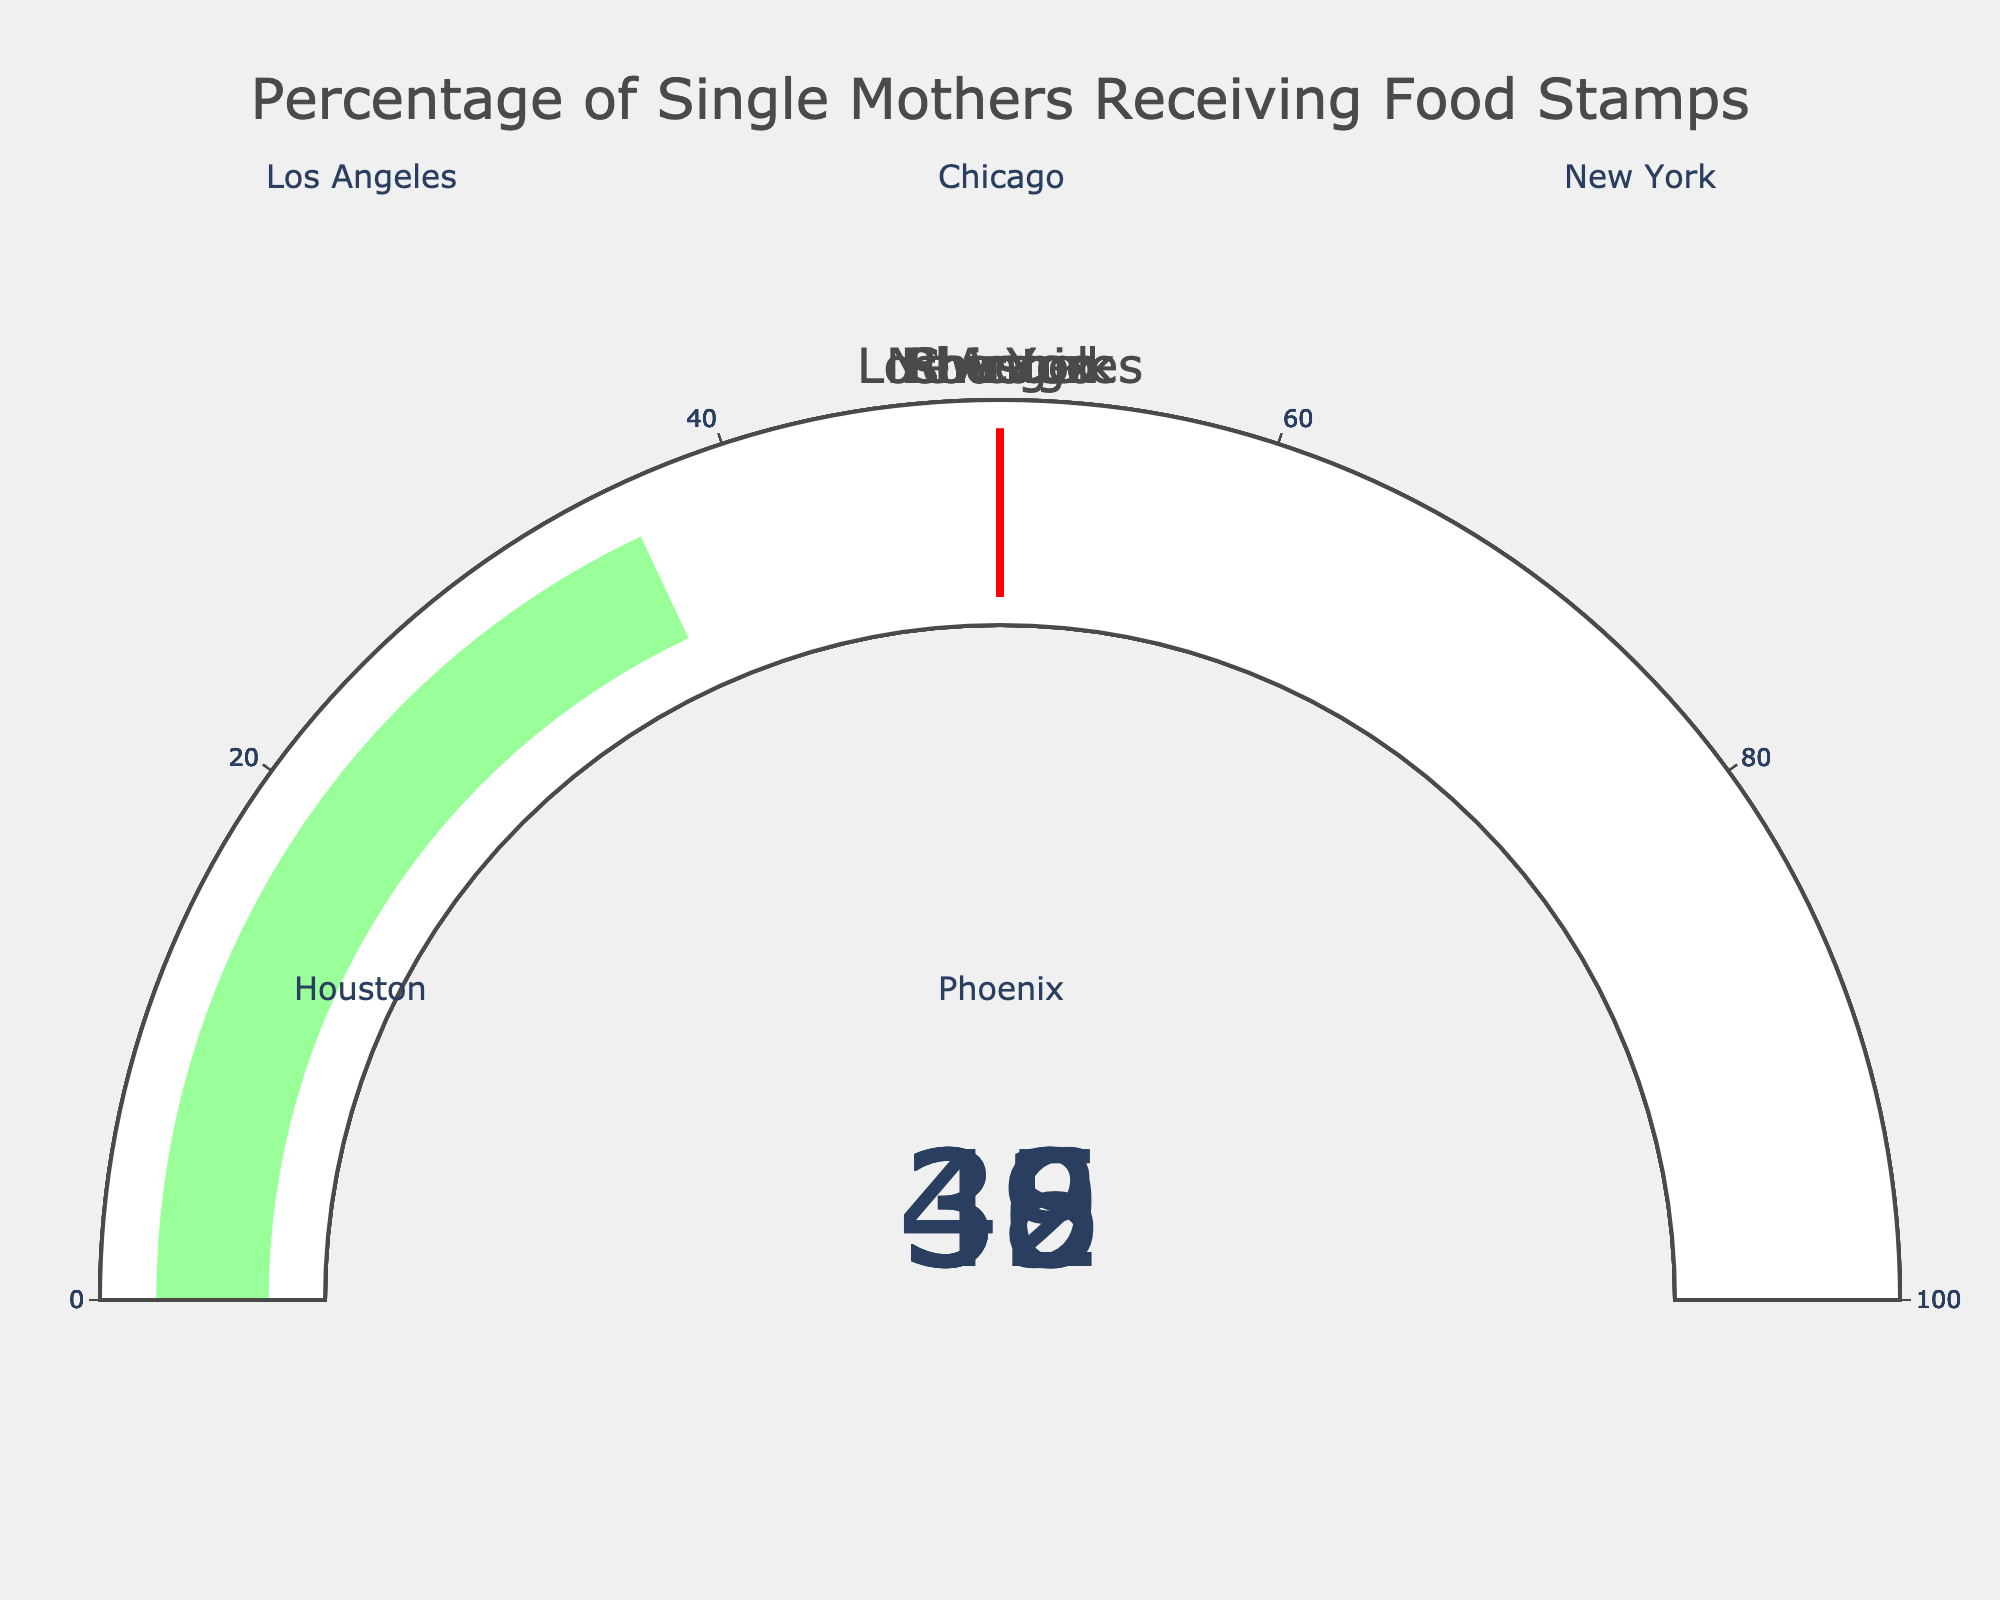What is the title of the figure? The title of the figure is located at the top and it indicates the main subject of the chart. The title reads "Percentage of Single Mothers Receiving Food Stamps".
Answer: Percentage of Single Mothers Receiving Food Stamps Which city has the highest percentage of single mothers receiving food stamps? Observe the gauge charts and locate the highest percentage value. New York has the highest value at 45%.
Answer: New York How many cities have a percentage of 40% or higher? Count the gauge charts with values 40% or higher. Los Angeles (42%) and New York (45%) meet this criterion, making a total of 2 cities.
Answer: 2 What is the average percentage of single mothers receiving food stamps across all the cities shown? Sum the percentages of all cities and divide by the number of cities. (Los Angeles: 42 + Chicago: 38 + New York: 45 + Houston: 39 + Phoenix: 36) / 5 = 200 / 5 = 40%.
Answer: 40% Which city has the lowest percentage of single mothers receiving food stamps? Compare the values on each gauge chart and identify the lowest percentage. Phoenix has the lowest value at 36%.
Answer: Phoenix What is the difference in the percentage of single mothers receiving food stamps between the city with the highest and the city with the lowest value? Subtract the lowest percentage value from the highest. New York (45%) - Phoenix (36%) = 9%.
Answer: 9% Is the percentage of single mothers receiving food stamps greater in Houston or Chicago? Compare the gauge values for Houston and Chicago. Houston's percentage is 39% and Chicago's is 38%. So, Houston's percentage is greater.
Answer: Houston If another city had a percentage of 43%, where would it rank among the cities shown? Compare the new percentage with existing values: 42 (Los Angeles), 38 (Chicago), 45 (New York), 39 (Houston), and 36 (Phoenix). The new value of 43% would be ranked between Los Angeles (42%) and New York (45%).
Answer: Between Los Angeles and New York What is the combined percentage of single mothers receiving food stamps in Chicago and Houston? Add the percentages for Chicago and Houston. Chicago: 38% + Houston: 39% = 77%.
Answer: 77% Do any cities have exactly the same percentage of single mothers receiving food stamps? Examine the values in each gauge chart. No two cities have the same percentage values.
Answer: No 